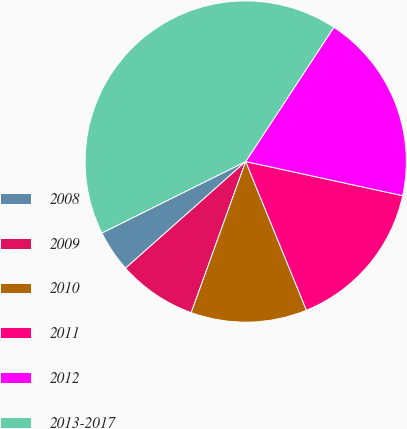Convert chart. <chart><loc_0><loc_0><loc_500><loc_500><pie_chart><fcel>2008<fcel>2009<fcel>2010<fcel>2011<fcel>2012<fcel>2013-2017<nl><fcel>4.21%<fcel>7.94%<fcel>11.68%<fcel>15.42%<fcel>19.16%<fcel>41.59%<nl></chart> 